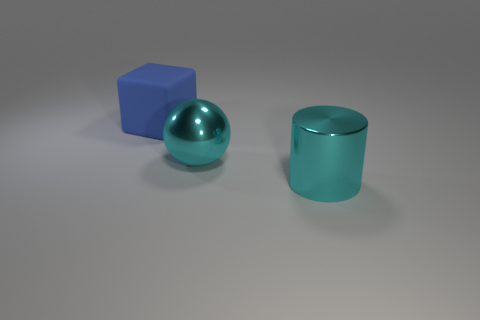Add 3 tiny green rubber balls. How many objects exist? 6 Subtract all blocks. How many objects are left? 2 Add 2 big cyan metal things. How many big cyan metal things exist? 4 Subtract 0 purple cubes. How many objects are left? 3 Subtract all large yellow things. Subtract all big metallic objects. How many objects are left? 1 Add 2 large rubber blocks. How many large rubber blocks are left? 3 